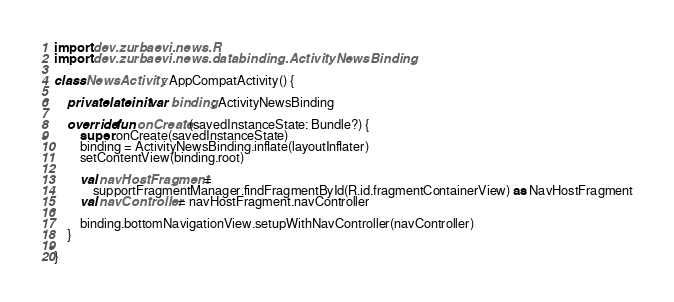<code> <loc_0><loc_0><loc_500><loc_500><_Kotlin_>import dev.zurbaevi.news.R
import dev.zurbaevi.news.databinding.ActivityNewsBinding

class NewsActivity : AppCompatActivity() {

    private lateinit var binding: ActivityNewsBinding

    override fun onCreate(savedInstanceState: Bundle?) {
        super.onCreate(savedInstanceState)
        binding = ActivityNewsBinding.inflate(layoutInflater)
        setContentView(binding.root)

        val navHostFragment =
            supportFragmentManager.findFragmentById(R.id.fragmentContainerView) as NavHostFragment
        val navController = navHostFragment.navController

        binding.bottomNavigationView.setupWithNavController(navController)
    }

}</code> 